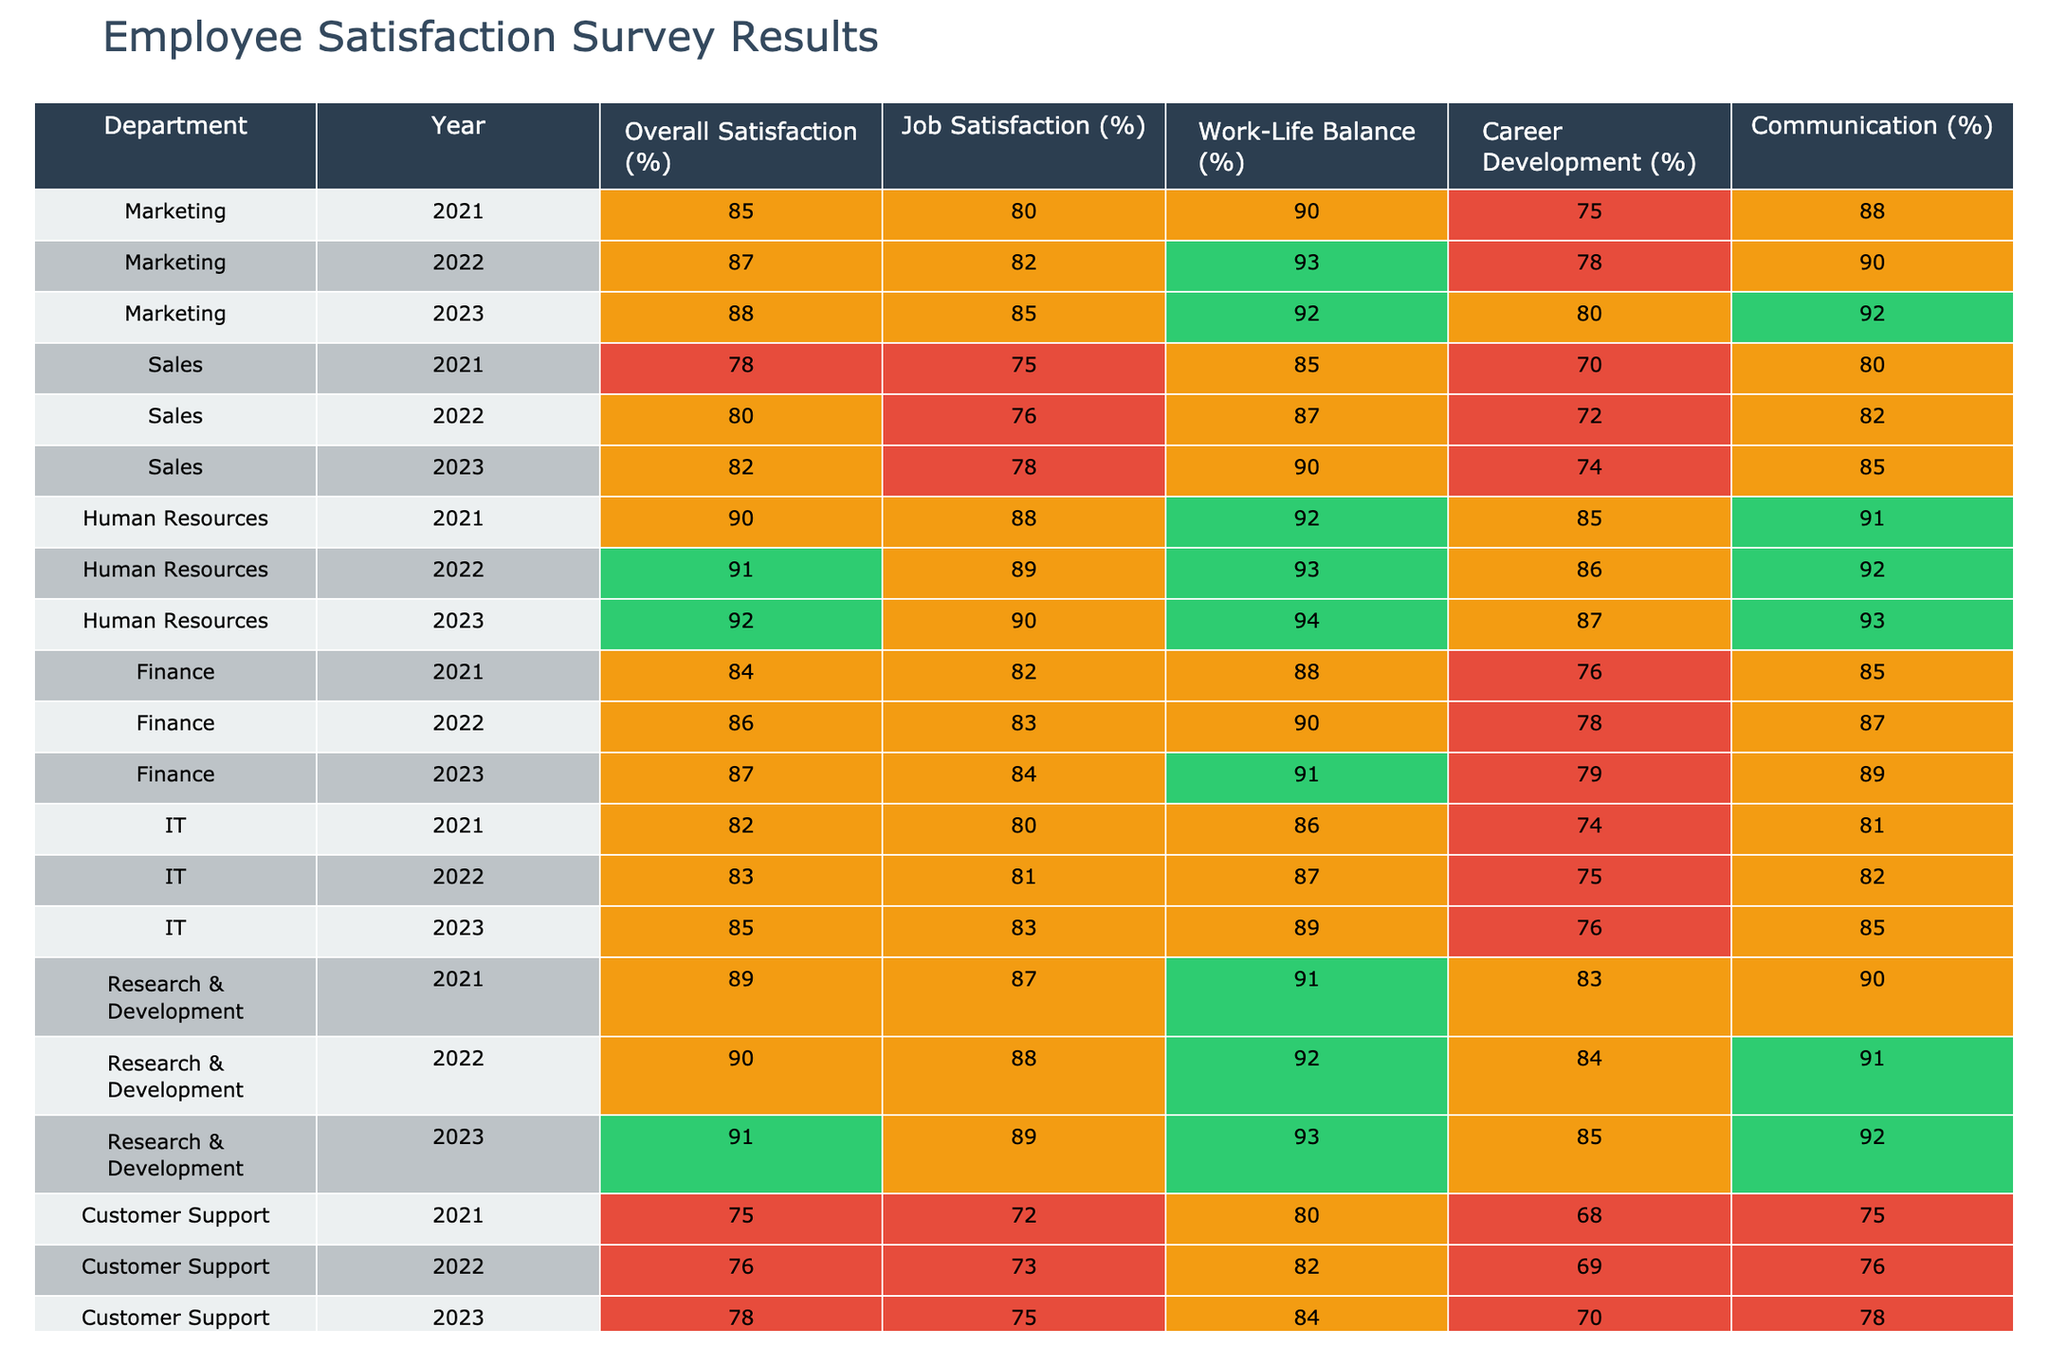What was the overall satisfaction percentage for the Human Resources department in 2023? Referring to the table, the value for the Human Resources department in 2023 under the "Overall Satisfaction (%)" column is 92.
Answer: 92 What department had the highest job satisfaction in 2021? Looking at the "Job Satisfaction (%)" column for the year 2021, the department with the highest percentage is Human Resources with 88%.
Answer: Human Resources Which year did the Sales department achieve the highest work-life balance satisfaction? Comparing the "Work-Life Balance (%)" values for the Sales department across the years, 90% in 2023 is the highest.
Answer: 2023 Was the overall satisfaction percentage for Finance higher in 2022 or 2023? The "Overall Satisfaction (%)" for Finance is 86% in 2022 and 87% in 2023. Since 87% is greater than 86%, 2023 had the higher percentage.
Answer: 2023 Calculate the average overall satisfaction for the IT department from 2021 to 2023. The overall satisfaction percentages for IT from 2021 to 2023 are 82%, 83%, and 85%. Summing these gives 82 + 83 + 85 = 250. Dividing by 3 (the number of years) gives an average of 250 / 3 = 83.33.
Answer: 83.33 Did the Research & Development department improve its Communication score from 2021 to 2023? The Communication percentages for Research & Development in 2021, 2022, and 2023 are 90%, 91%, and 92% respectively. Since 92% is greater than 90%, there was an improvement.
Answer: Yes What is the difference in career development satisfaction between Marketing in 2021 and Human Resources in 2023? The Career Development (%) for Marketing in 2021 is 75%, and for Human Resources in 2023 it is 87%. The difference is 87 - 75 = 12.
Answer: 12 Which department had a decrease in overall satisfaction from 2022 to 2023? Looking at the overall satisfaction percentages: Marketing (87% to 88%), Sales (80% to 82%), Human Resources (91% to 92%), Finance (86% to 87%), IT (83% to 85%), R&D (90% to 91%), and Customer Support (76% to 78%). Operations increased from 83% to 85%. Thus, none had a decrease.
Answer: No department In what year did Customer Support have the lowest recorded job satisfaction? Checking the job satisfaction percentages for Customer Support: 72% in 2021, 73% in 2022, and 75% in 2023. The lowest was 72% in 2021.
Answer: 2021 What was the trend in overall satisfaction for the Marketing department from 2021 to 2023? The overall satisfaction percentages for Marketing are 85% in 2021, 87% in 2022, and 88% in 2023. Observing these values shows an increasing trend over the years.
Answer: Increasing trend 